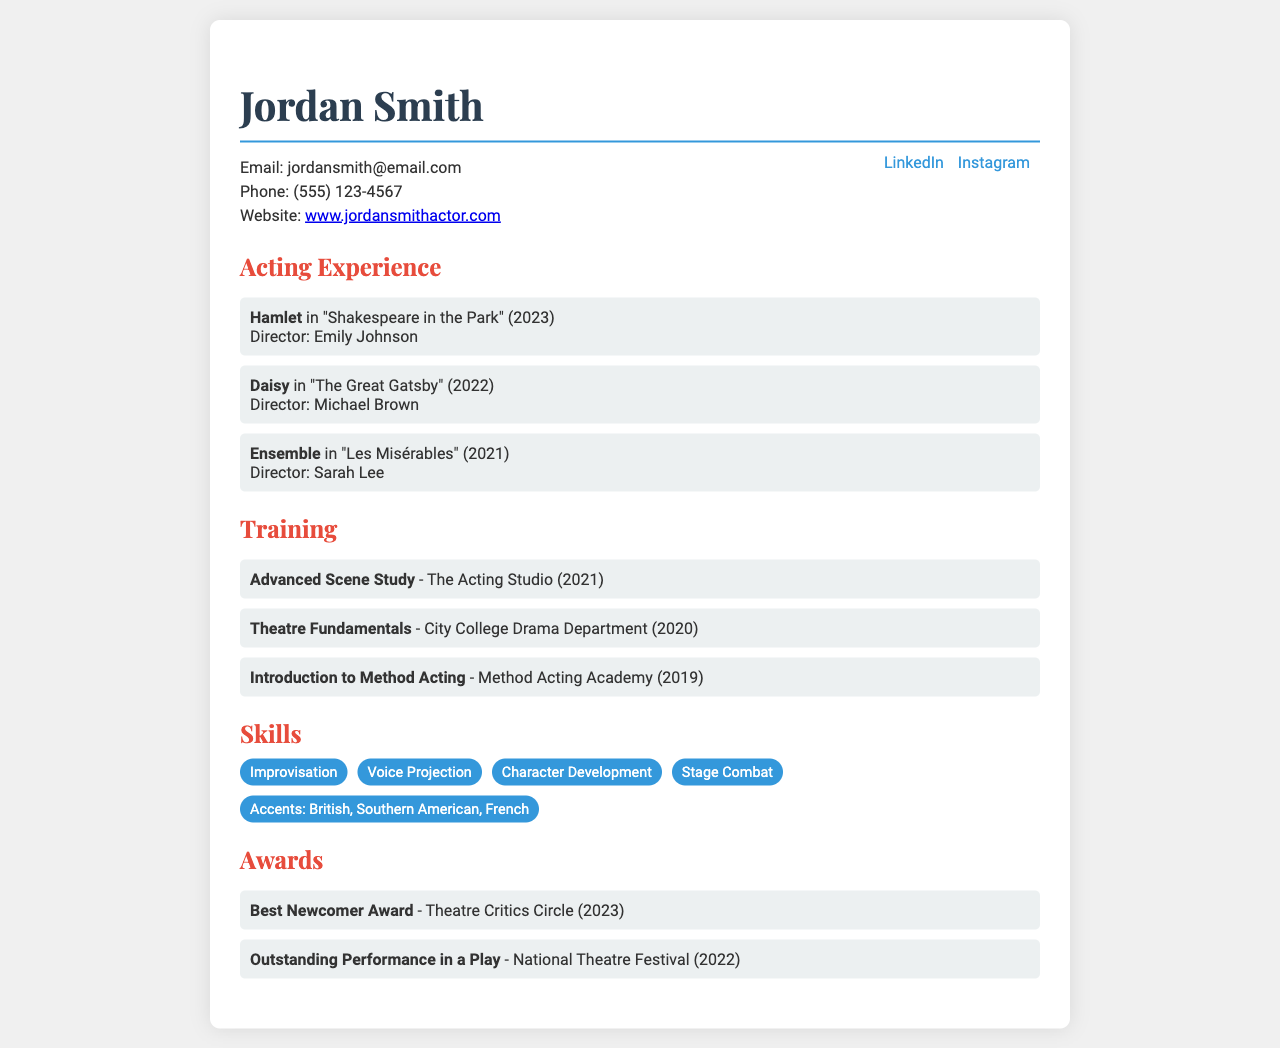what is the name of the actor? The actor's name is prominently displayed at the top of the resume.
Answer: Jordan Smith how many performances are listed under acting experience? The number of performances can be found by counting the list items in the acting experience section.
Answer: 3 which award did Jordan Smith receive in 2023? The specific award can be found in the awards section of the resume.
Answer: Best Newcomer Award where did Jordan Smith train in Advanced Scene Study? The training location is stated alongside the training name in the training section.
Answer: The Acting Studio what character did Jordan Smith play in "The Great Gatsby"? The character's name is mentioned directly in the acting experience section.
Answer: Daisy how many years of training are listed in total? This requires adding the years mentioned next to each training entry.
Answer: 3 list one accent skill mentioned in the document. This skill is part of the skills listed in the skills section of the resume.
Answer: British who directed "Les Misérables"? The director's name is provided in the acting experience section next to the performance title.
Answer: Sarah Lee what is Jordan Smith's email address? The email address is found in the contact information at the top of the resume.
Answer: jordansmith@email.com 